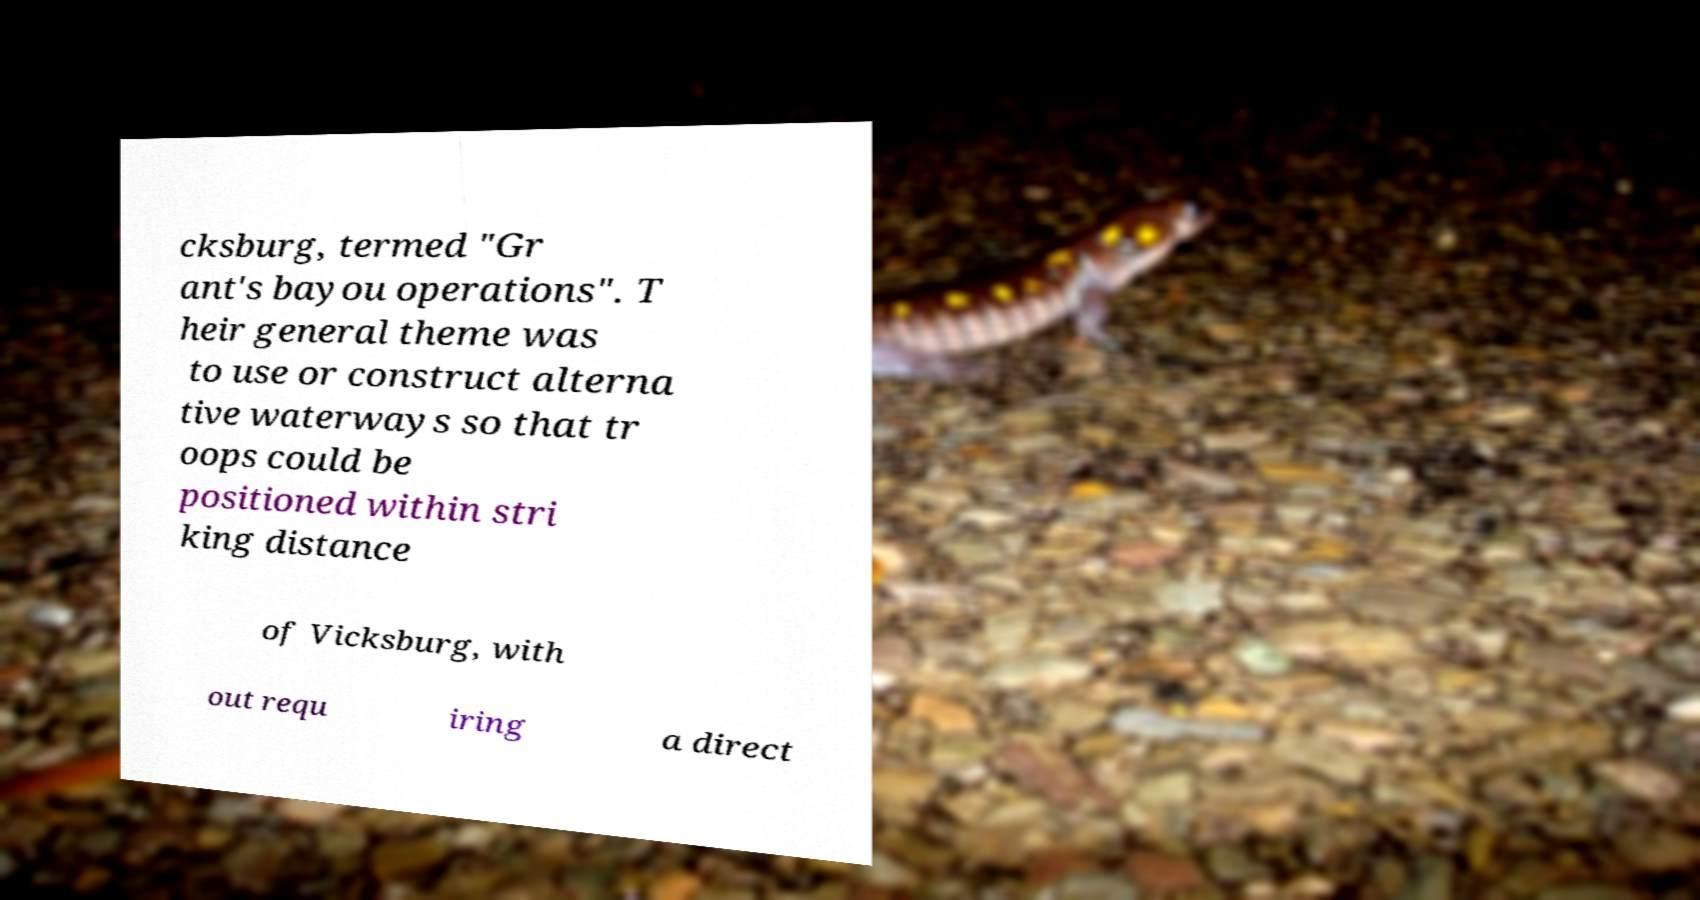There's text embedded in this image that I need extracted. Can you transcribe it verbatim? cksburg, termed "Gr ant's bayou operations". T heir general theme was to use or construct alterna tive waterways so that tr oops could be positioned within stri king distance of Vicksburg, with out requ iring a direct 